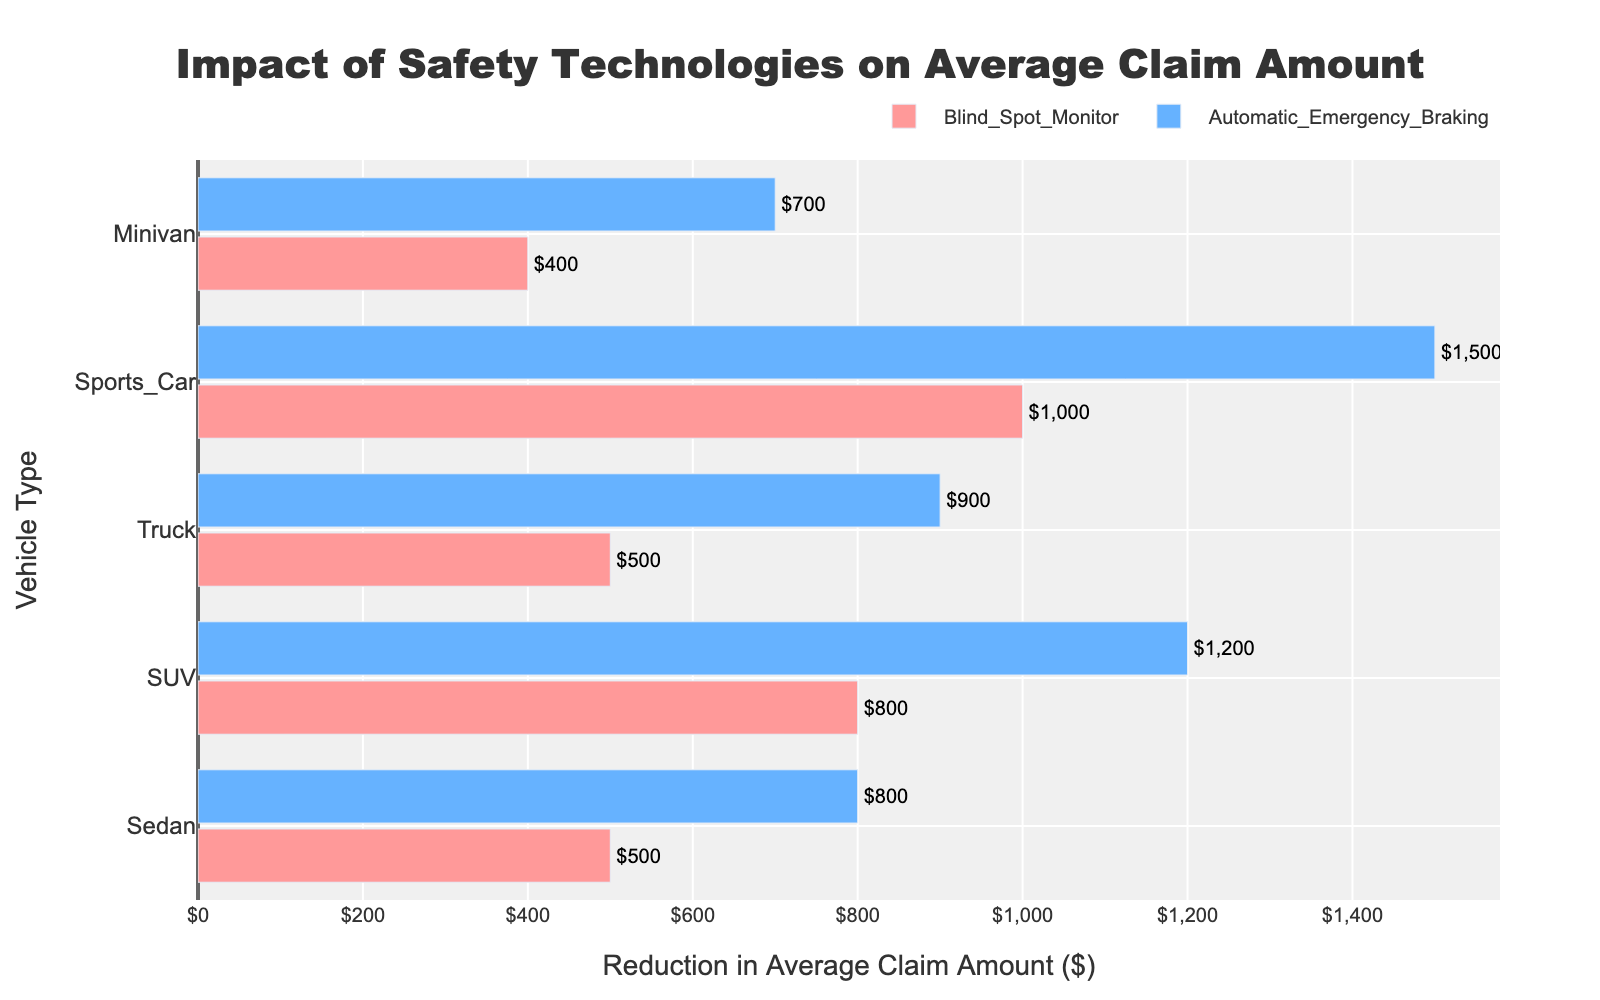Which safety technology led to the largest reduction in average claim amount for sedans? To find this, look for the bar representing the largest reduction in the 'Sedan' row. Determine the technology associated with this bar. The largest reduction corresponds to 'Automatic Emergency Braking' with a difference of $800.
Answer: Automatic Emergency Braking Which vehicle type had the smallest reduction in claim amount from Blind Spot Monitor technology? Compare the bars representing Blind Spot Monitor across all vehicle types. The smallest reduction is seen in 'Sports Car,' from 15000 to 14000, a difference of $1000.
Answer: Sports Car What's the total reduction in claim amount for SUVs with both safety technologies installed? Add the reductions due to 'Blind Spot Monitor' and 'Automatic Emergency Braking' for SUVs. Calculations: 7000 - 6200 = 800 and 7000 - 5800 = 1200. Total reduction = 800 + 1200 = 2000.
Answer: $2000 Which vehicle type shows the greatest overall reduction due to safety technologies? Assess the Vehicle_Type with the total reduction from both technologies. Calculate: Sedan (5000 - 4200 = 800 + 5000 - 4500 = 500 = 1300), SUV (7000 - 5800 = 1200 + 7000 - 6200 = 800 = 2000), Truck (8000 - 7100 = 900 + 8000 - 7500 = 500 = 1400), Sports Car (15000 - 13500 = 1500 + 15000 - 14000 = 1000 = 2500), Minivan (6000 - 5300 = 700 + 6000 - 5600 = 400 = 1100). Sports Car has the largest total (2500).
Answer: Sports Car Compare the reductions in claim amounts between the technologies for trucks. Which technology has a greater impact? Evaluate the difference for trucks: Blind Spot Monitor (8000 - 7500 = 500) vs. Automatic Emergency Braking (8000 - 7100 = 900). Automatic Emergency Braking has a greater reduction of 900.
Answer: Automatic Emergency Braking How does the average claim amount reduction for Blind Spot Monitor in SUVs compare to that in Minivans? Compare the reduction amounts by subtracting current claim amounts from 'No_Safety_Tech' amount. SUV: 7000 - 6200 = 800, Minivan: 6000 - 5600 = 400.
Answer: The reduction in SUVs is greater by $400 